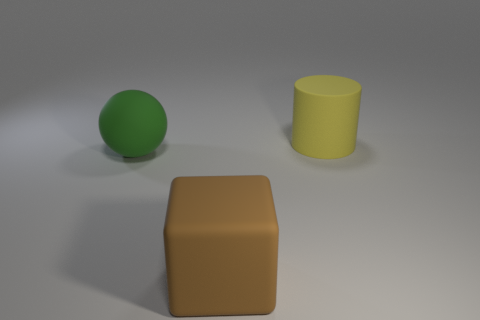Add 1 red rubber objects. How many objects exist? 4 Subtract all blocks. How many objects are left? 2 Subtract 0 green cubes. How many objects are left? 3 Subtract all cyan matte blocks. Subtract all yellow cylinders. How many objects are left? 2 Add 1 green rubber balls. How many green rubber balls are left? 2 Add 2 big cyan rubber cylinders. How many big cyan rubber cylinders exist? 2 